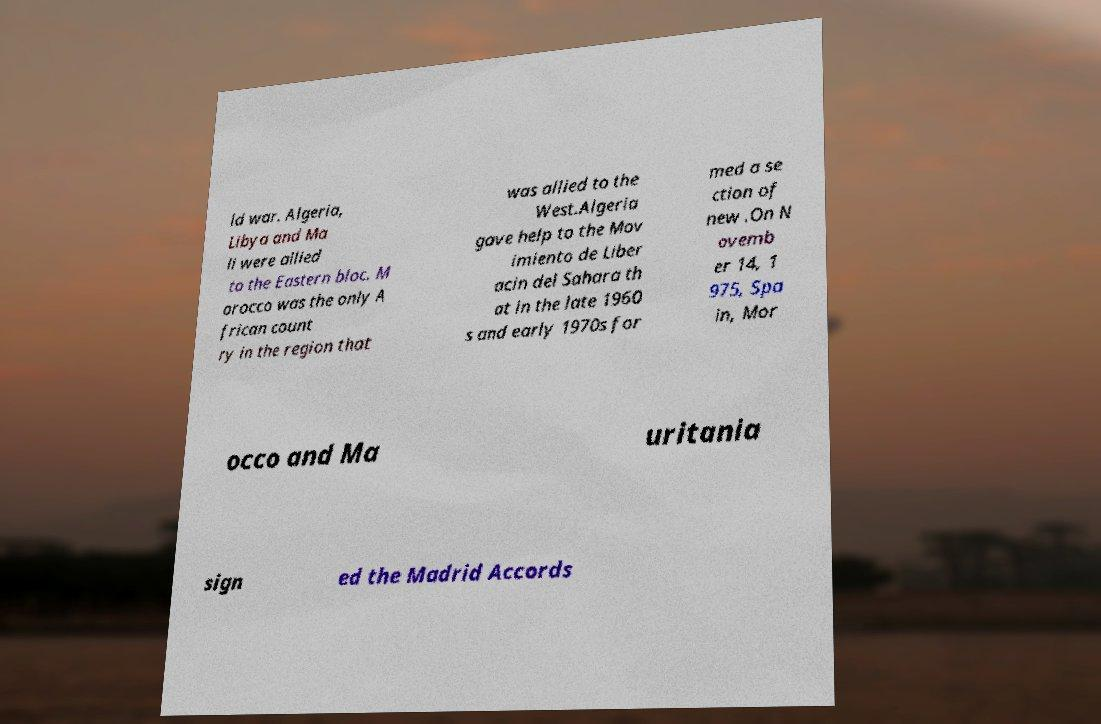I need the written content from this picture converted into text. Can you do that? ld war. Algeria, Libya and Ma li were allied to the Eastern bloc. M orocco was the only A frican count ry in the region that was allied to the West.Algeria gave help to the Mov imiento de Liber acin del Sahara th at in the late 1960 s and early 1970s for med a se ction of new .On N ovemb er 14, 1 975, Spa in, Mor occo and Ma uritania sign ed the Madrid Accords 